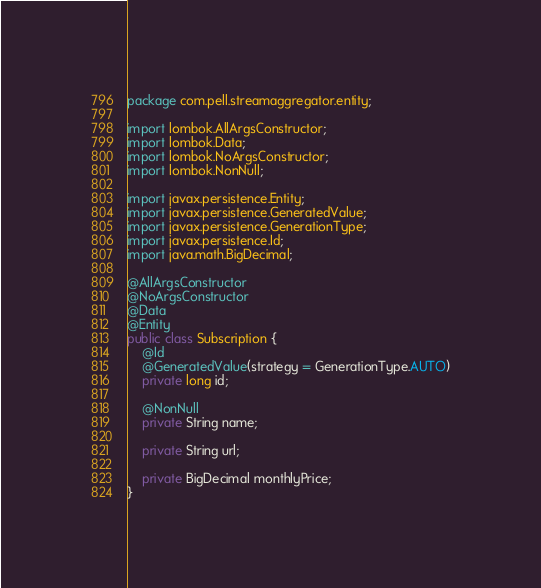Convert code to text. <code><loc_0><loc_0><loc_500><loc_500><_Java_>package com.pell.streamaggregator.entity;

import lombok.AllArgsConstructor;
import lombok.Data;
import lombok.NoArgsConstructor;
import lombok.NonNull;

import javax.persistence.Entity;
import javax.persistence.GeneratedValue;
import javax.persistence.GenerationType;
import javax.persistence.Id;
import java.math.BigDecimal;

@AllArgsConstructor
@NoArgsConstructor
@Data
@Entity
public class Subscription {
    @Id
    @GeneratedValue(strategy = GenerationType.AUTO)
    private long id;

    @NonNull
    private String name;

    private String url;

    private BigDecimal monthlyPrice;
}
</code> 